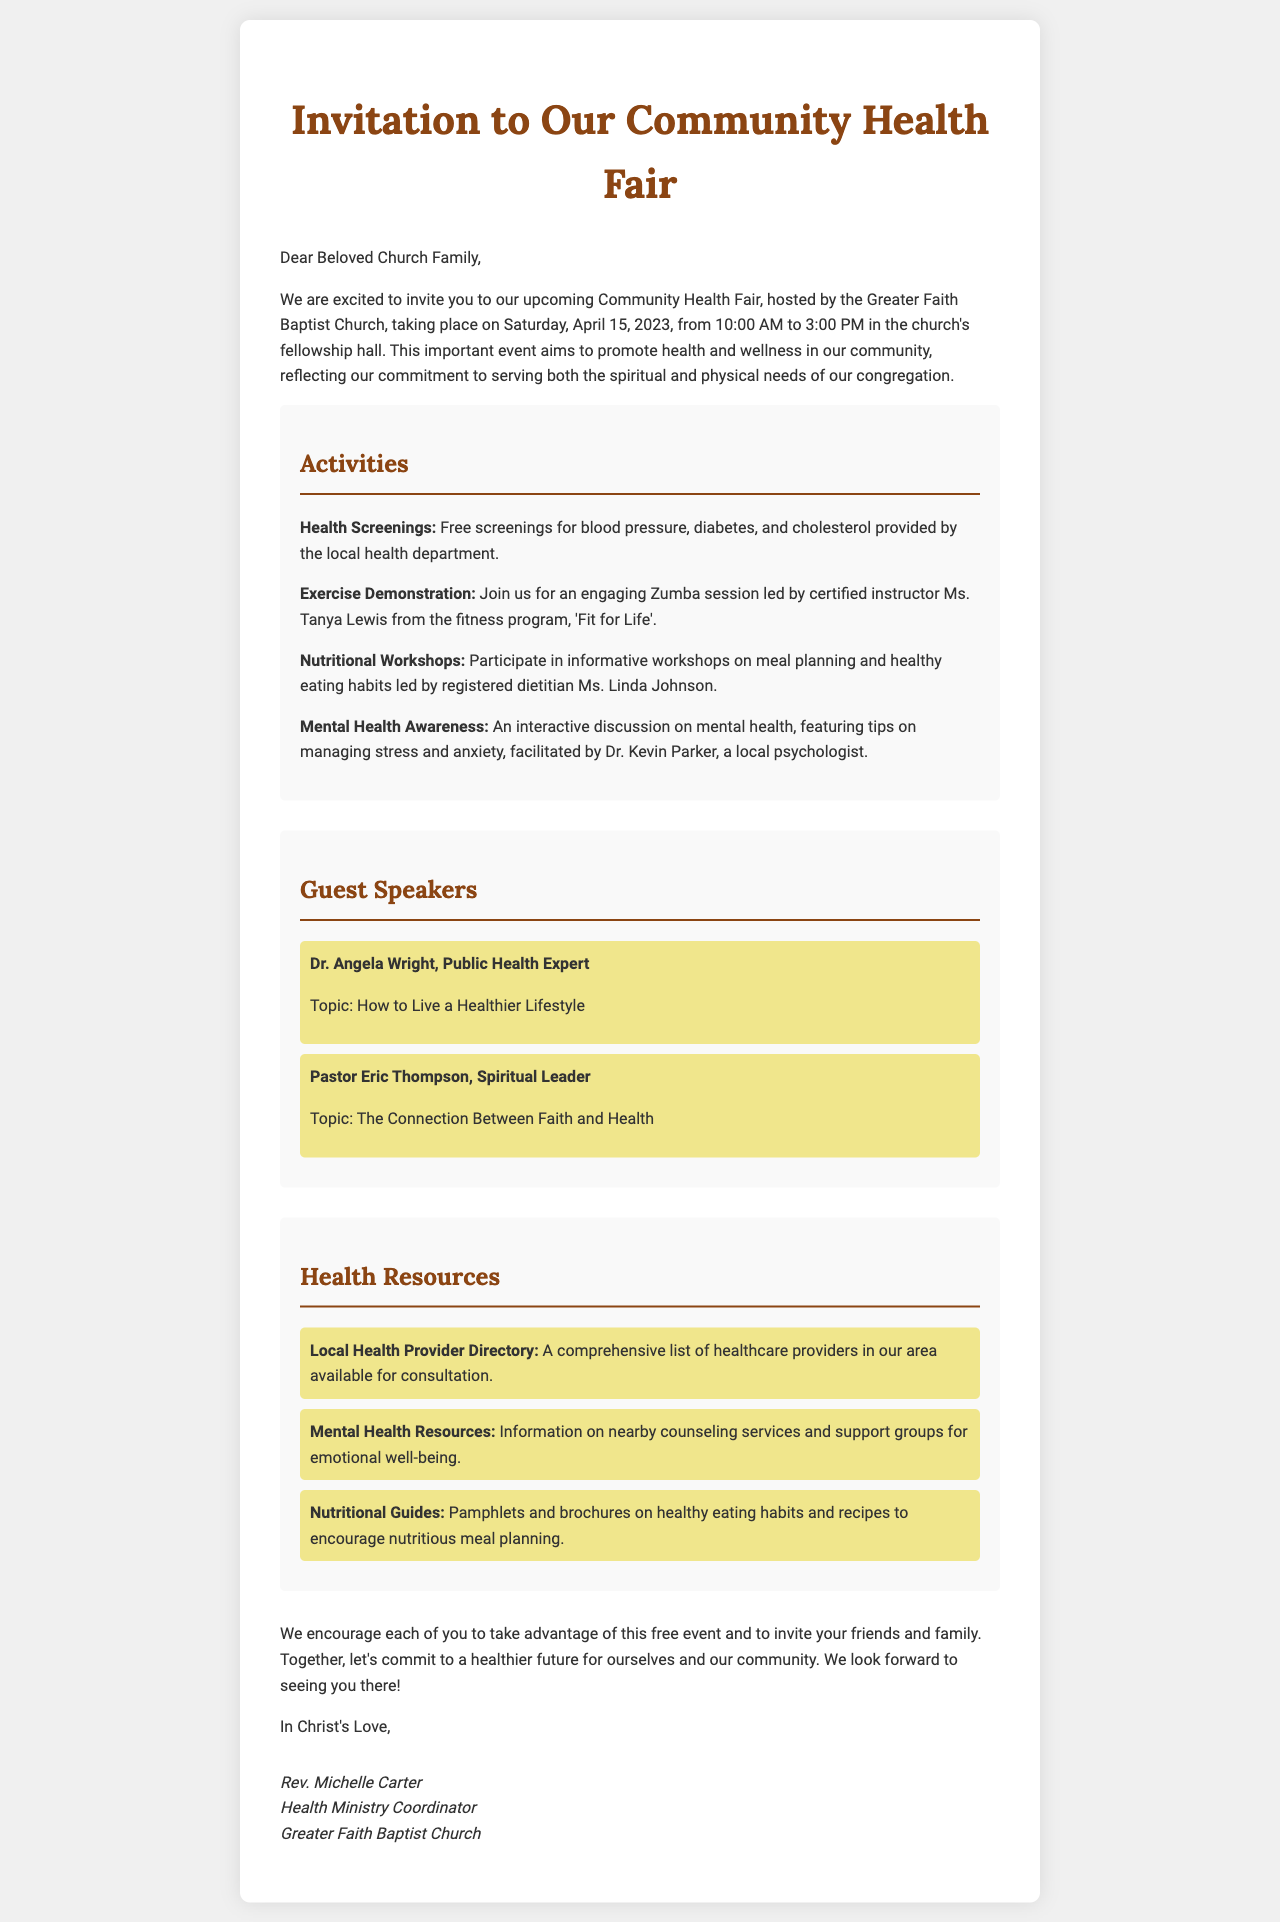What is the name of the church hosting the event? The document states that the event is hosted by Greater Faith Baptist Church.
Answer: Greater Faith Baptist Church What date is the Community Health Fair taking place? The invitation specifies that the Health Fair is on Saturday, April 15, 2023.
Answer: April 15, 2023 What time will the Health Fair start? According to the letter, the Health Fair starts at 10:00 AM.
Answer: 10:00 AM Who is leading the Zumba session? The document mentions that Ms. Tanya Lewis will lead the Zumba session.
Answer: Ms. Tanya Lewis What is one topic that Dr. Angela Wright will discuss? The invitation lists that Dr. Angela Wright will discuss "How to Live a Healthier Lifestyle."
Answer: How to Live a Healthier Lifestyle What kind of health screenings will be provided? The document states there will be free screenings for blood pressure, diabetes, and cholesterol.
Answer: Blood pressure, diabetes, and cholesterol What resource is provided for mental health? The letter mentions that there will be information on nearby counseling services and support groups.
Answer: Counseling services and support groups What does Pastor Eric Thompson's talk focus on? The document indicates that Pastor Eric Thompson's talk focuses on "The Connection Between Faith and Health."
Answer: The Connection Between Faith and Health What is the primary purpose of the Health Fair? The invitation emphasizes that the Health Fair aims to promote health and wellness in the community.
Answer: Promote health and wellness in the community 